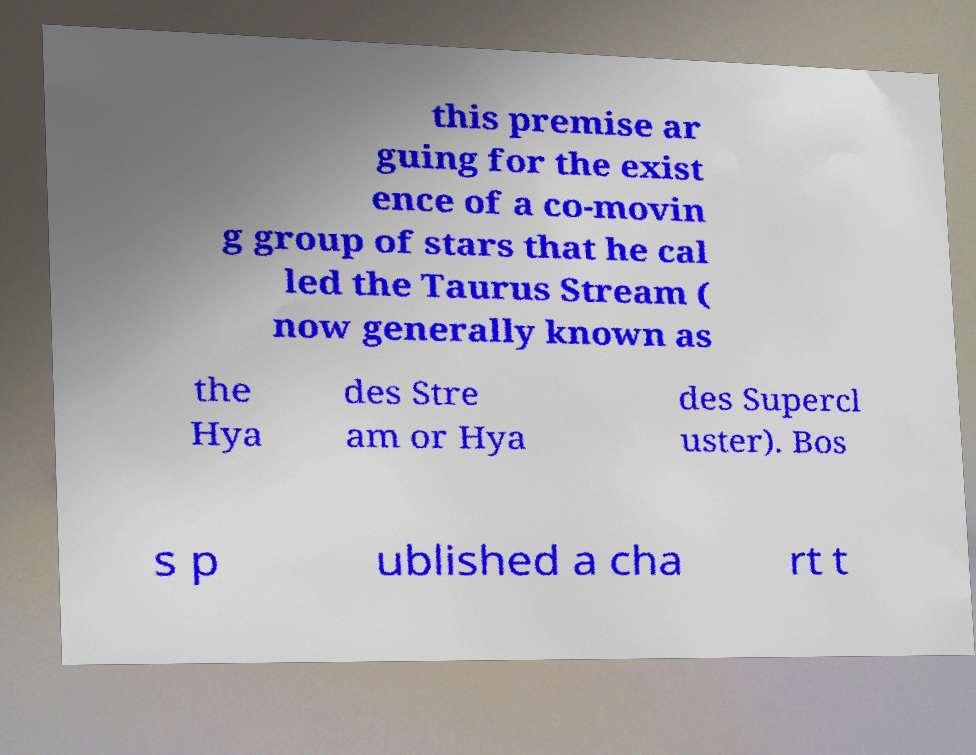I need the written content from this picture converted into text. Can you do that? this premise ar guing for the exist ence of a co-movin g group of stars that he cal led the Taurus Stream ( now generally known as the Hya des Stre am or Hya des Supercl uster). Bos s p ublished a cha rt t 